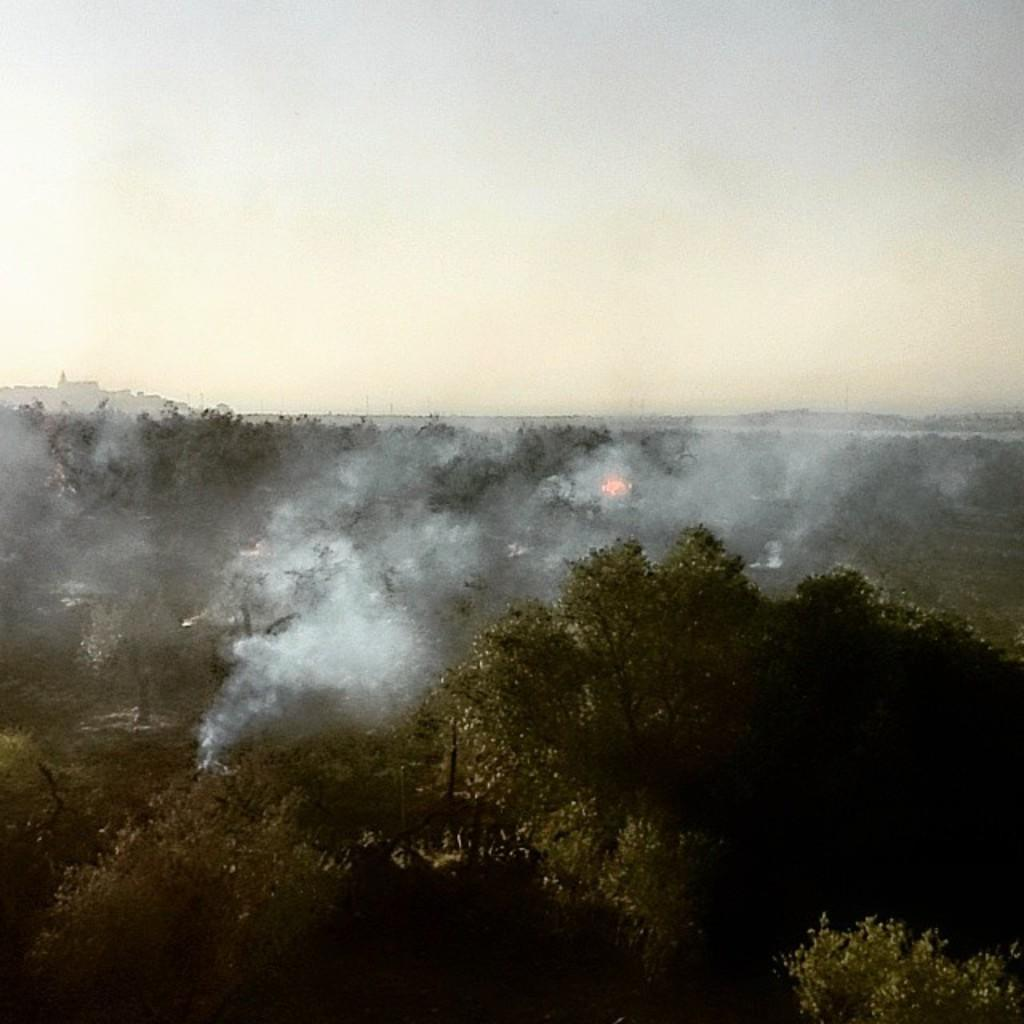What type of vegetation can be seen in the image? There are trees in the image. Can you describe any specific details about the trees? Smoke is coming out of the trees in the center of the image. What grade is the ship mentioned in the image? There is no ship present in the image, so the concept of a grade does not apply. 